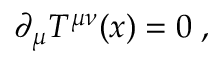Convert formula to latex. <formula><loc_0><loc_0><loc_500><loc_500>\partial _ { \mu } T ^ { \mu \nu } ( x ) = 0 \, ,</formula> 